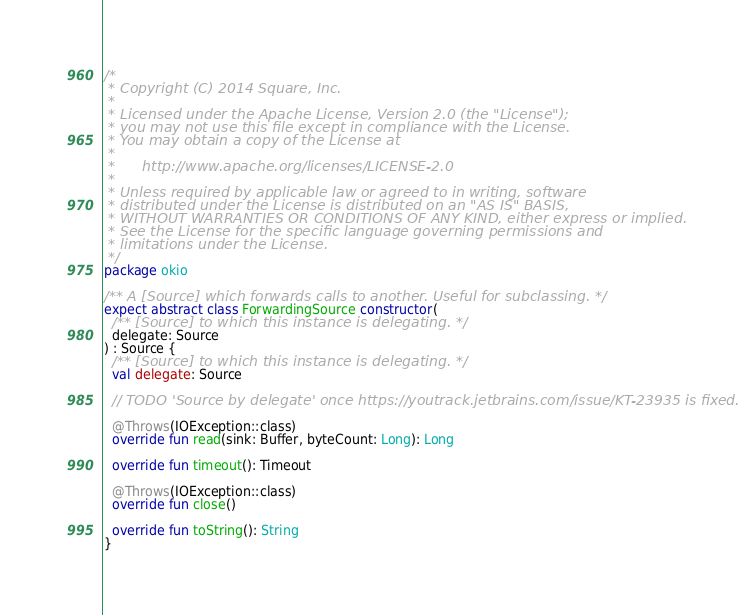<code> <loc_0><loc_0><loc_500><loc_500><_Kotlin_>/*
 * Copyright (C) 2014 Square, Inc.
 *
 * Licensed under the Apache License, Version 2.0 (the "License");
 * you may not use this file except in compliance with the License.
 * You may obtain a copy of the License at
 *
 *      http://www.apache.org/licenses/LICENSE-2.0
 *
 * Unless required by applicable law or agreed to in writing, software
 * distributed under the License is distributed on an "AS IS" BASIS,
 * WITHOUT WARRANTIES OR CONDITIONS OF ANY KIND, either express or implied.
 * See the License for the specific language governing permissions and
 * limitations under the License.
 */
package okio

/** A [Source] which forwards calls to another. Useful for subclassing. */
expect abstract class ForwardingSource constructor(
  /** [Source] to which this instance is delegating. */
  delegate: Source
) : Source {
  /** [Source] to which this instance is delegating. */
  val delegate: Source

  // TODO 'Source by delegate' once https://youtrack.jetbrains.com/issue/KT-23935 is fixed.

  @Throws(IOException::class)
  override fun read(sink: Buffer, byteCount: Long): Long

  override fun timeout(): Timeout

  @Throws(IOException::class)
  override fun close()

  override fun toString(): String
}
</code> 